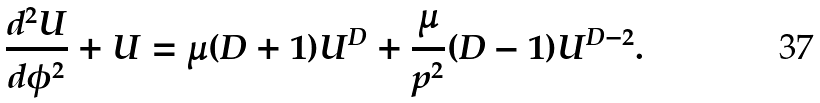<formula> <loc_0><loc_0><loc_500><loc_500>\frac { d ^ { 2 } U } { d { \phi } ^ { 2 } } + U = \mu ( D + 1 ) U ^ { D } + \frac { \mu } { p ^ { 2 } } ( D - 1 ) U ^ { D - 2 } .</formula> 